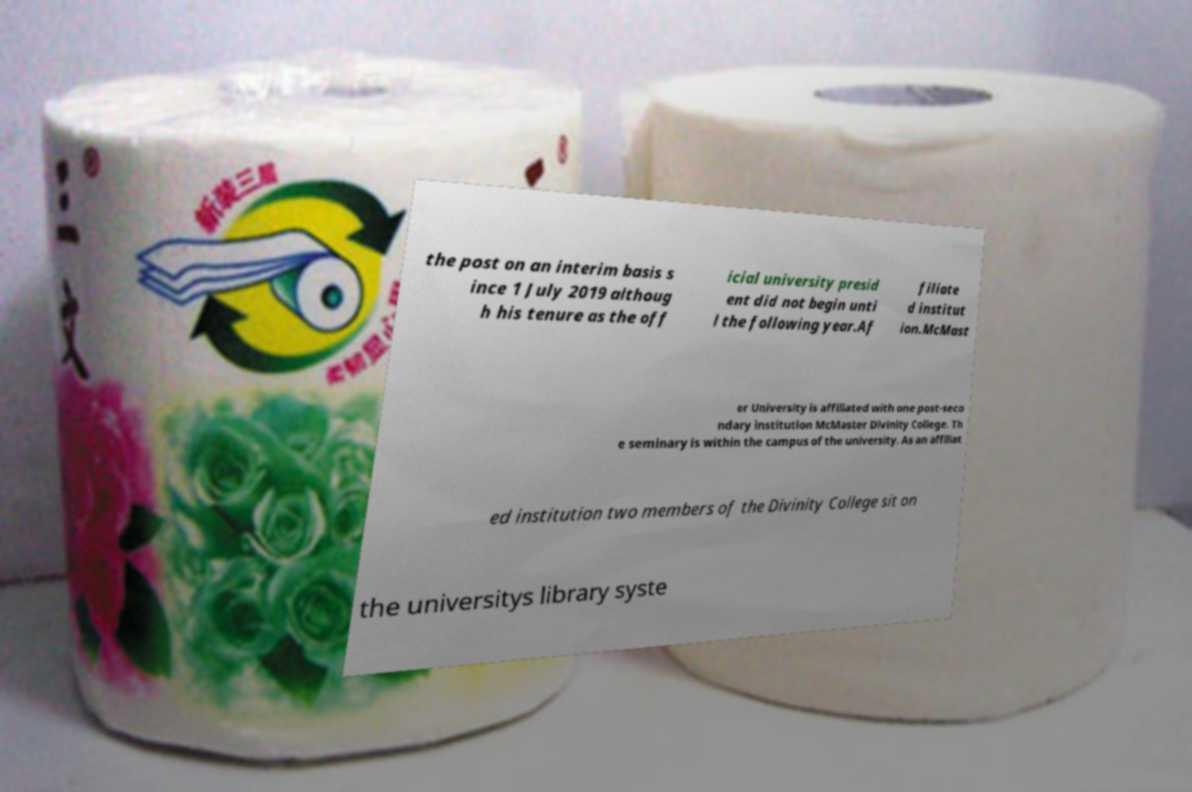There's text embedded in this image that I need extracted. Can you transcribe it verbatim? the post on an interim basis s ince 1 July 2019 althoug h his tenure as the off icial university presid ent did not begin unti l the following year.Af filiate d institut ion.McMast er University is affiliated with one post-seco ndary institution McMaster Divinity College. Th e seminary is within the campus of the university. As an affiliat ed institution two members of the Divinity College sit on the universitys library syste 